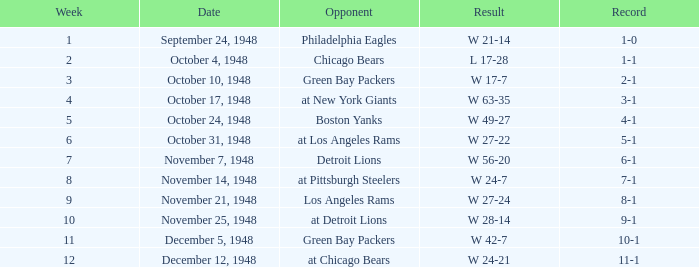What was the record for December 5, 1948? 10-1. 